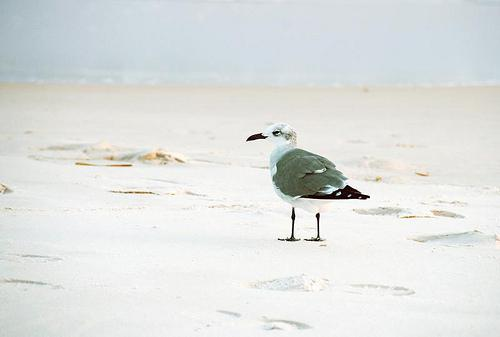Question: why can't we see the bird's right eye?
Choices:
A. It is closed.
B. The bird is turned to the left.
C. Head is down.
D. Head is turned.
Answer with the letter. Answer: B 